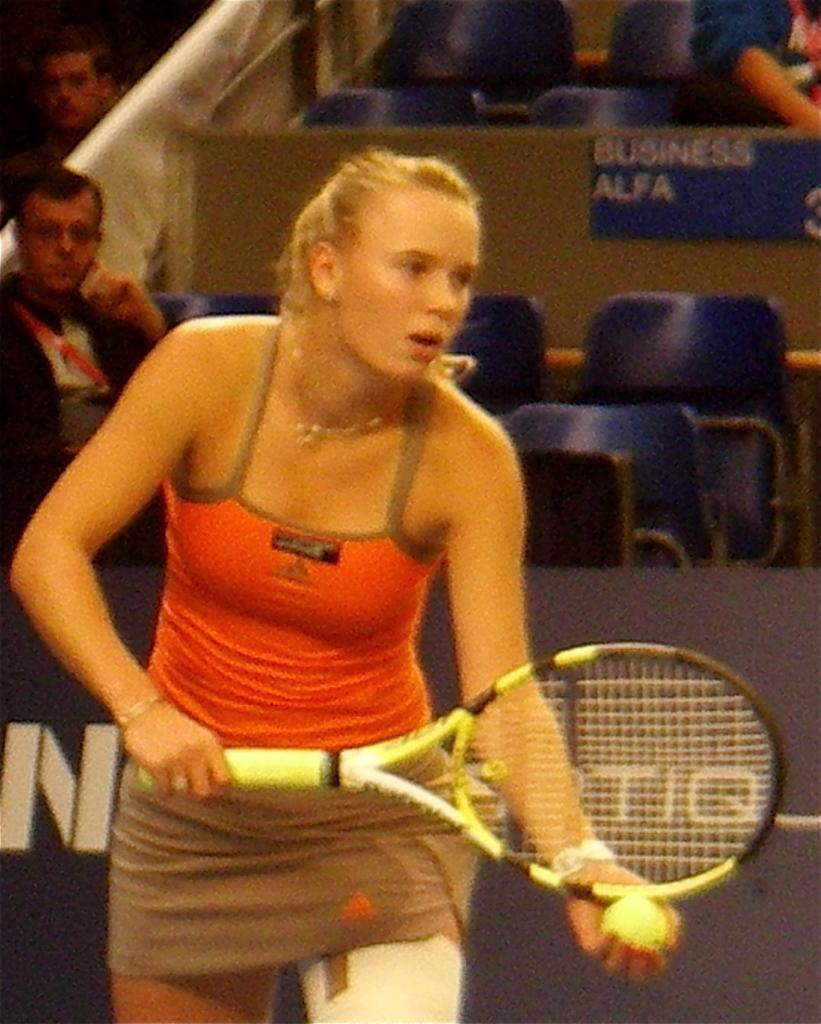Who is the main subject in the image? There is a woman in the image. What is the woman doing in the image? The woman is playing tennis. What objects is the woman holding in the image? The woman is holding a racket and a ball in the image. What can be seen in the background of the image? There are chairs, a hoarding, and people seated and looking at the game in the background of the image. What type of prose can be heard being recited by the wren in the garden in the image? There is no wren or garden present in the image, and therefore no such activity can be observed. 